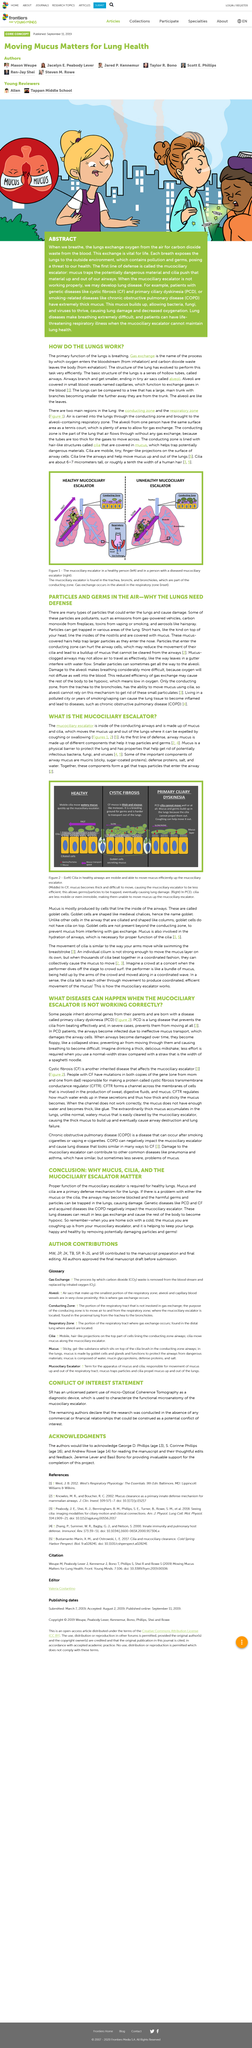Point out several critical features in this image. The figure 1 illustrates the mucociliary escalator in both a healthy person and a person with a diseased mucociliary escalator. Chronic obstructive pulmonary disease (COPD) is an acronym that stands for a progressive lung disease characterized by chronic inflammation and obstruction of the airways, leading to difficulty breathing, coughing, and wheezing. Primary Ciliary Dyskinesia is a disorder characterized by abnormal movement of the cilia, which are tiny hair-like structures found in the respiratory and urinary tracts. The acronym 'PCD' stands for this condition. The mucociliary escalator, located within the conducting airways, is composed of mucus and cilia, which work together to move mucus up and out of the lungs, allowing for expulsion by coughing or swallowing. The two main regions in the lungs are the conducting zone and the respiratory zone. 